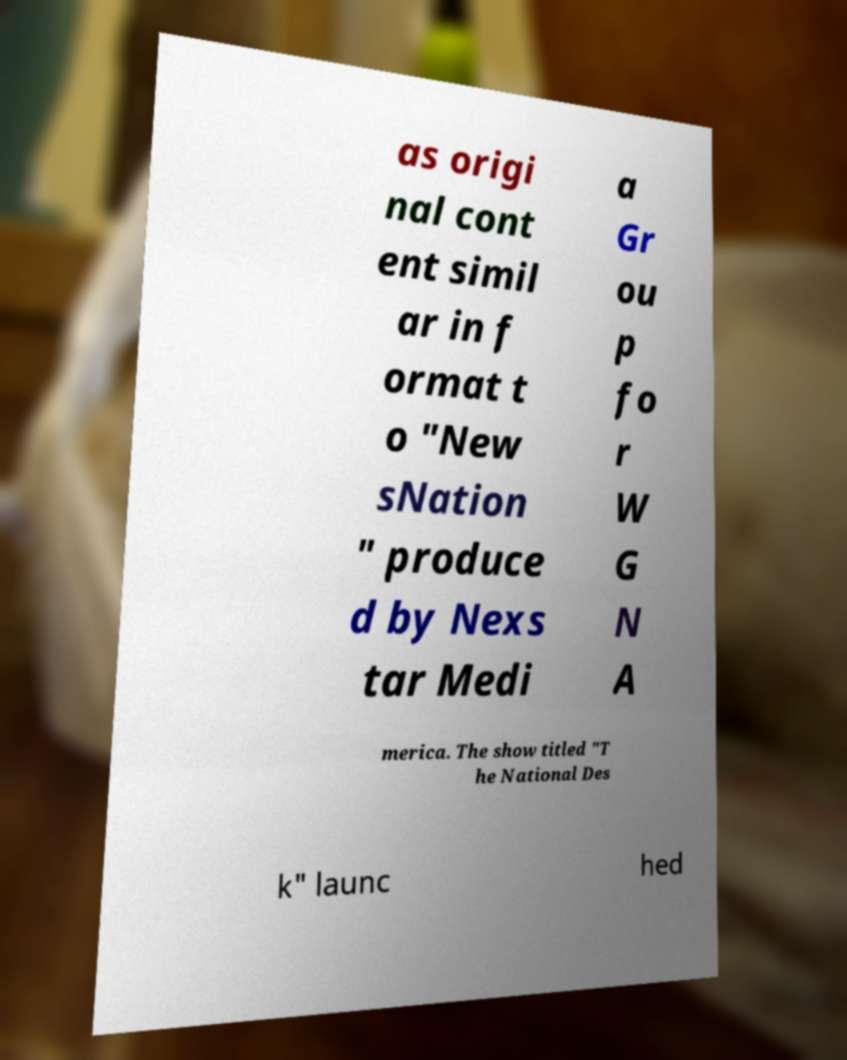I need the written content from this picture converted into text. Can you do that? as origi nal cont ent simil ar in f ormat t o "New sNation " produce d by Nexs tar Medi a Gr ou p fo r W G N A merica. The show titled "T he National Des k" launc hed 